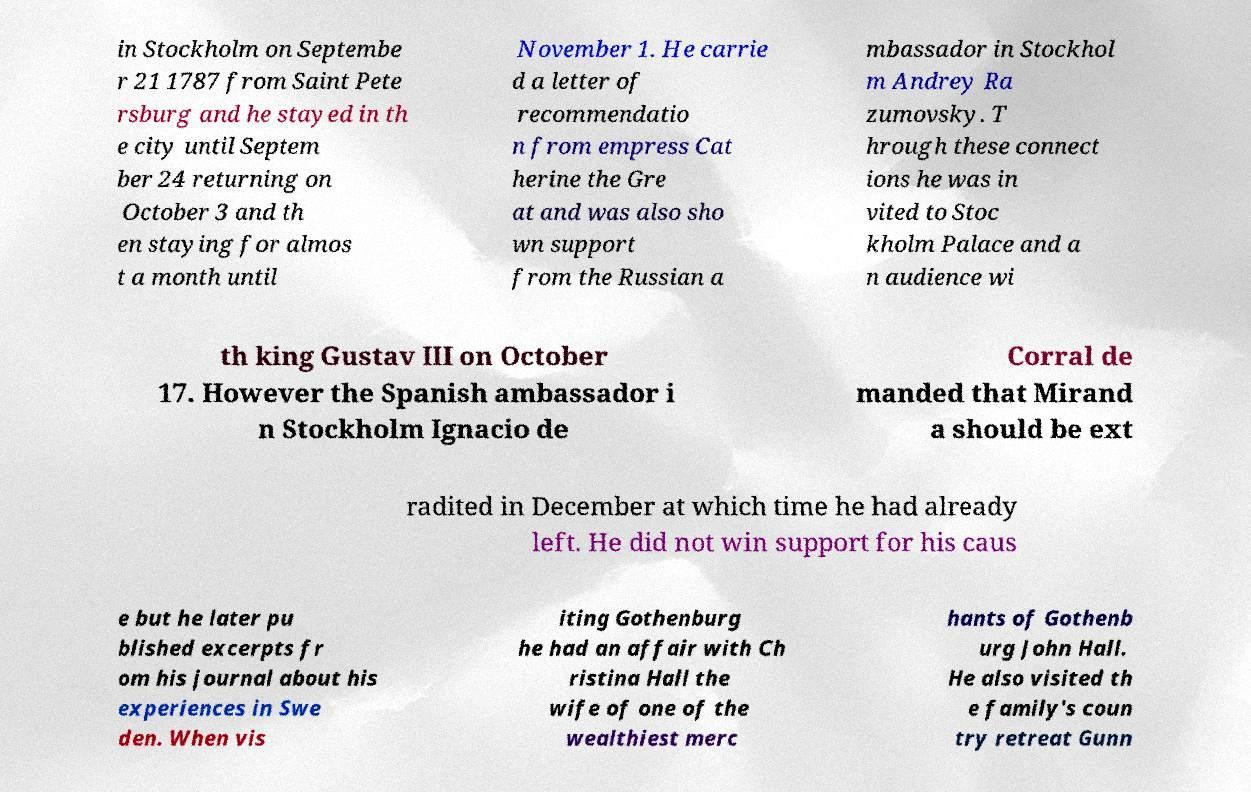Could you extract and type out the text from this image? in Stockholm on Septembe r 21 1787 from Saint Pete rsburg and he stayed in th e city until Septem ber 24 returning on October 3 and th en staying for almos t a month until November 1. He carrie d a letter of recommendatio n from empress Cat herine the Gre at and was also sho wn support from the Russian a mbassador in Stockhol m Andrey Ra zumovsky. T hrough these connect ions he was in vited to Stoc kholm Palace and a n audience wi th king Gustav III on October 17. However the Spanish ambassador i n Stockholm Ignacio de Corral de manded that Mirand a should be ext radited in December at which time he had already left. He did not win support for his caus e but he later pu blished excerpts fr om his journal about his experiences in Swe den. When vis iting Gothenburg he had an affair with Ch ristina Hall the wife of one of the wealthiest merc hants of Gothenb urg John Hall. He also visited th e family's coun try retreat Gunn 